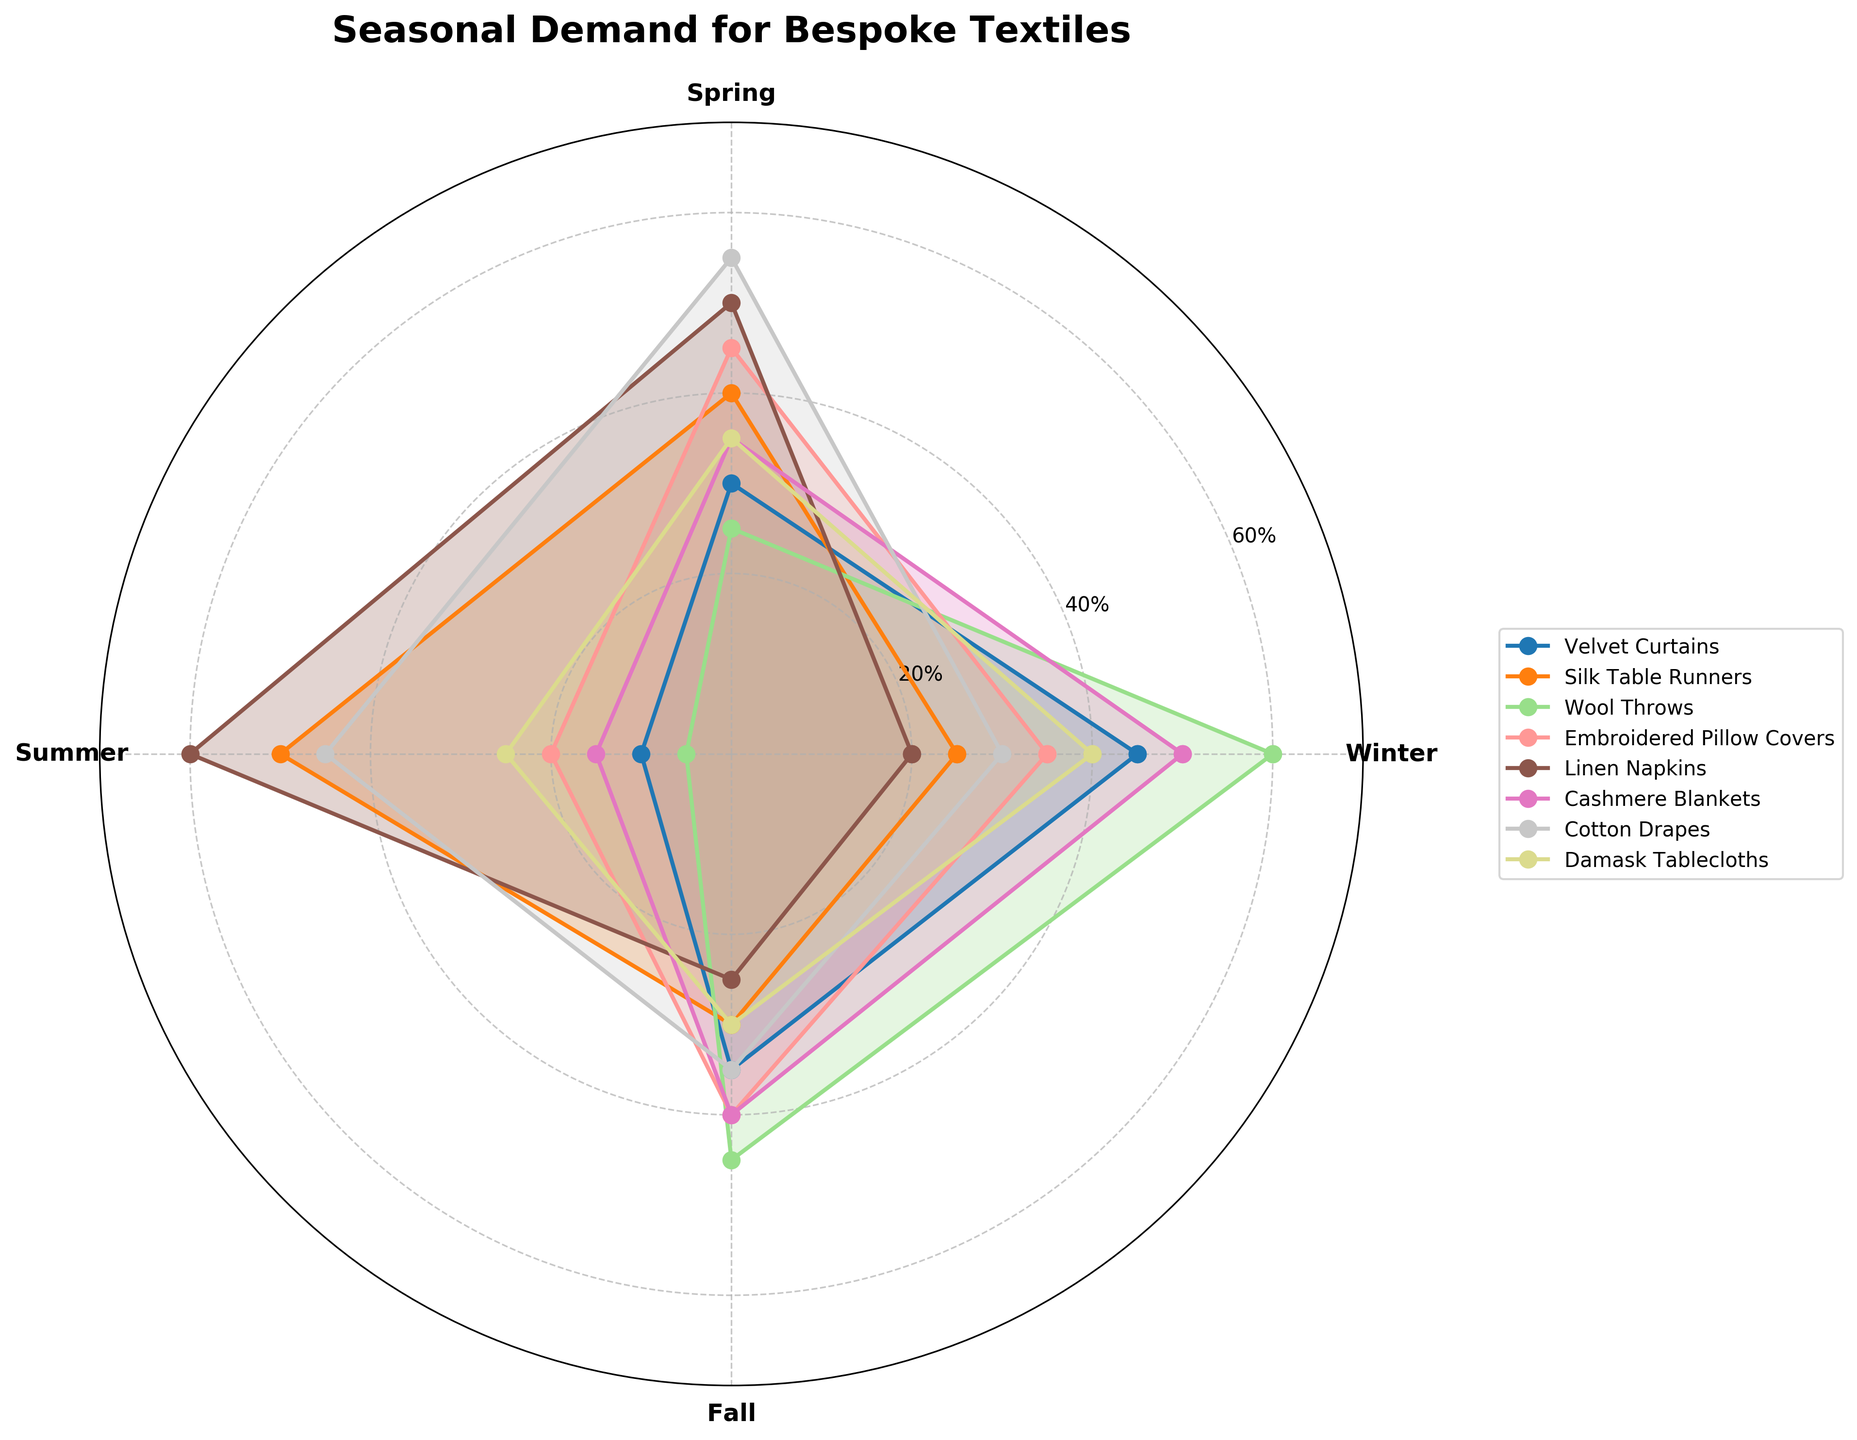what is the title of the figure? The title is usually located at the top of the figure. In this case, it reads "Seasonal Demand for Bespoke Textiles".
Answer: Seasonal Demand for Bespoke Textiles which category has the highest demand in winter? Each category's demand is visually represented by the area covered in winter. The Wool Throws category extends the farthest for winter, indicating the highest demand.
Answer: Wool Throws which seasons does embroidered pillow covers have higher demand than cashmere blankets? By comparing the plot lines for Embroidered Pillow Covers and Cashmere Blankets across seasons, Embroidered Pillow Covers are higher in Spring and Summer.
Answer: Spring, Summer what is the overall seasonal trend for linen napkins? Observing the Linen Napkins' plot line, there's a peak during Summer, descending in Fall, and a rise again in Spring. Winter is the lowest.
Answer: Lowest in Winter, peaks in Summer which textile category has the most consistent demand across seasons? Consistency can be observed as having less variance in the plot line across seasons. Damask Tablecloths have similar demands in all four seasons.
Answer: Damask Tablecloths what's the average demand for velvet curtains across all seasons? Sum the demand values of Velvet Curtains across the four seasons (45 + 30 + 10 + 35 = 120) and divide by the number of seasons (4). The average is 120/4.
Answer: 30 which season shows the highest demand for the majority of categories? Observing the plot lines, Spring and Summer often show higher peaks. Among them, Summer has the highest demand for three categories.
Answer: Summer what's the demand difference between silk table runners and cotton drapes in spring? By looking at Spring values, Silk Table Runners are at 40 and Cotton Drapes at 55. The difference is 55 - 40.
Answer: 15 which two categories have the closest demand values in winter? Comparing values visually in Winter, Silk Table Runners (25) and Linen Napkins (20) are closest.
Answer: Silk Table Runners and Linen Napkins what's the peak demand value among all categories and seasons? The highest value on the radial axis is the peak demand. Wool Throws in Winter reach 60 which is the highest on the chart.
Answer: 60 